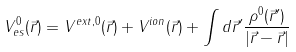<formula> <loc_0><loc_0><loc_500><loc_500>V _ { e s } ^ { 0 } ( \vec { r } ) = V ^ { e x t , 0 } ( \vec { r } ) + V ^ { i o n } ( \vec { r } ) + \int d \vec { r } ^ { \prime } \frac { \rho ^ { 0 } ( \vec { r } ^ { \prime } ) } { | \vec { r } - \vec { r } | }</formula> 